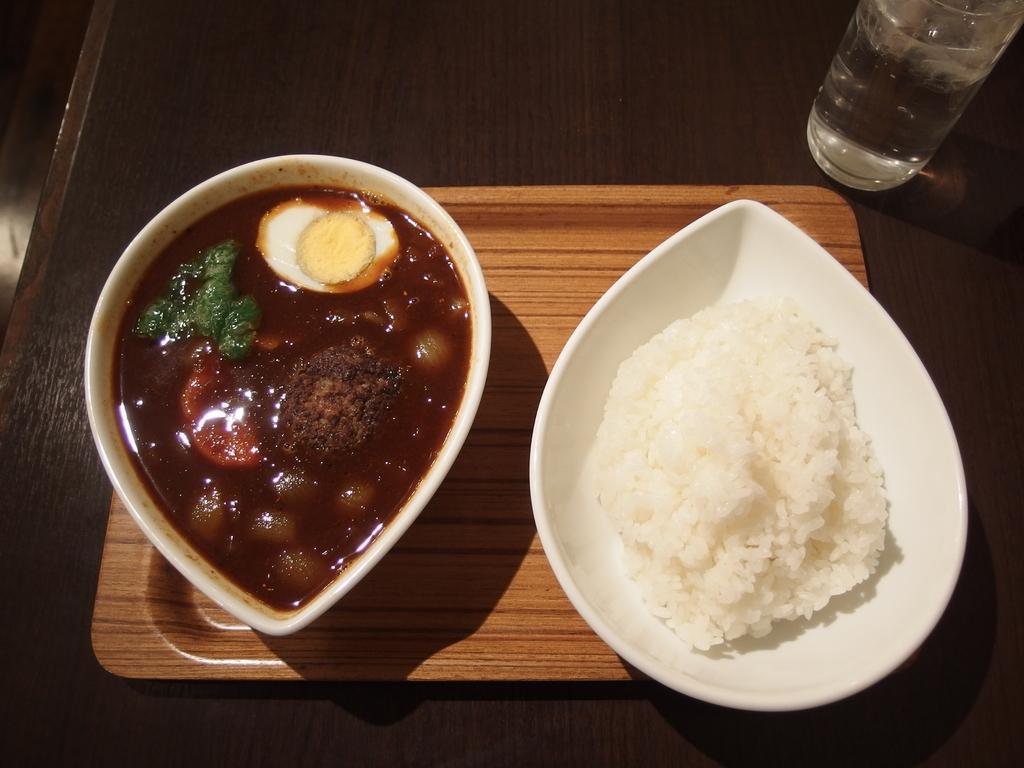In one or two sentences, can you explain what this image depicts? In this picture I can see food items in the bowls. I can see the glass. I can see the plate. I can see the table. 